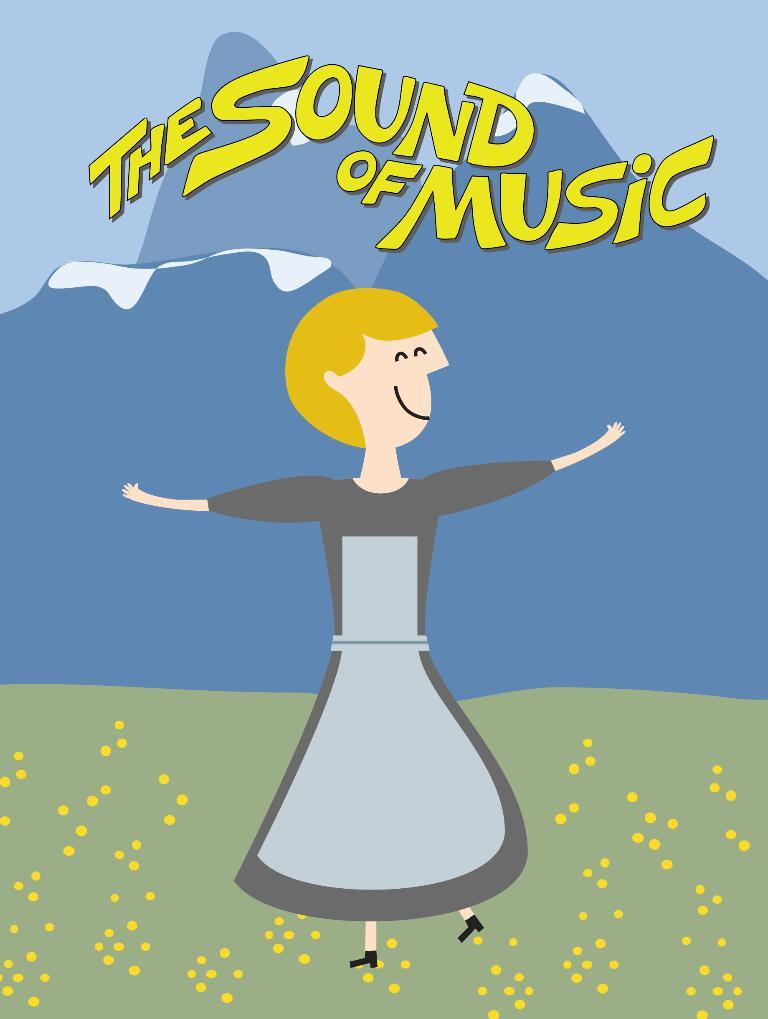What is present in the image that contains visual information? There is a poster in the image. What types of content can be found on the poster? The poster contains images and text. What type of haircut is depicted on the poster? There is no haircut depicted on the poster; it contains images and text, but none of them are related to a haircut. 